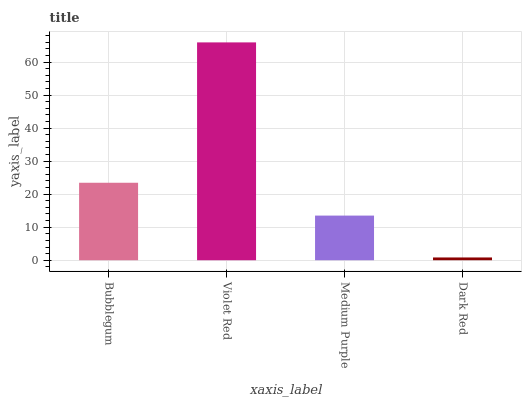Is Dark Red the minimum?
Answer yes or no. Yes. Is Violet Red the maximum?
Answer yes or no. Yes. Is Medium Purple the minimum?
Answer yes or no. No. Is Medium Purple the maximum?
Answer yes or no. No. Is Violet Red greater than Medium Purple?
Answer yes or no. Yes. Is Medium Purple less than Violet Red?
Answer yes or no. Yes. Is Medium Purple greater than Violet Red?
Answer yes or no. No. Is Violet Red less than Medium Purple?
Answer yes or no. No. Is Bubblegum the high median?
Answer yes or no. Yes. Is Medium Purple the low median?
Answer yes or no. Yes. Is Dark Red the high median?
Answer yes or no. No. Is Violet Red the low median?
Answer yes or no. No. 